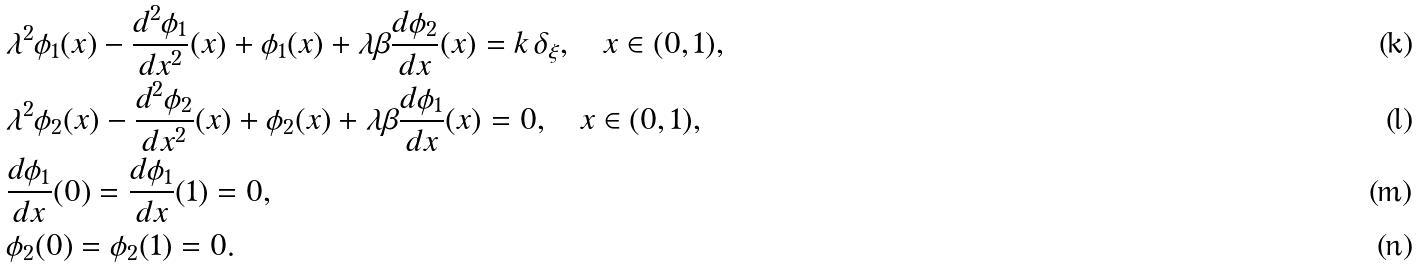Convert formula to latex. <formula><loc_0><loc_0><loc_500><loc_500>& \lambda ^ { 2 } \phi _ { 1 } ( x ) - \frac { d ^ { 2 } \phi _ { 1 } } { d x ^ { 2 } } ( x ) + \phi _ { 1 } ( x ) + \lambda \beta \frac { d \phi _ { 2 } } { d x } ( x ) = k \, \delta _ { \xi } , \quad x \in ( 0 , 1 ) , \\ & \lambda ^ { 2 } \phi _ { 2 } ( x ) - \frac { d ^ { 2 } \phi _ { 2 } } { d x ^ { 2 } } ( x ) + \phi _ { 2 } ( x ) + \lambda \beta \frac { d \phi _ { 1 } } { d x } ( x ) = 0 , \quad x \in ( 0 , 1 ) , \\ & \frac { d \phi _ { 1 } } { d x } ( 0 ) = \frac { d \phi _ { 1 } } { d x } ( 1 ) = 0 , \\ & \phi _ { 2 } ( 0 ) = \phi _ { 2 } ( 1 ) = 0 .</formula> 